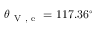Convert formula to latex. <formula><loc_0><loc_0><loc_500><loc_500>\theta _ { V , e } = 1 1 7 . 3 6 ^ { \circ }</formula> 